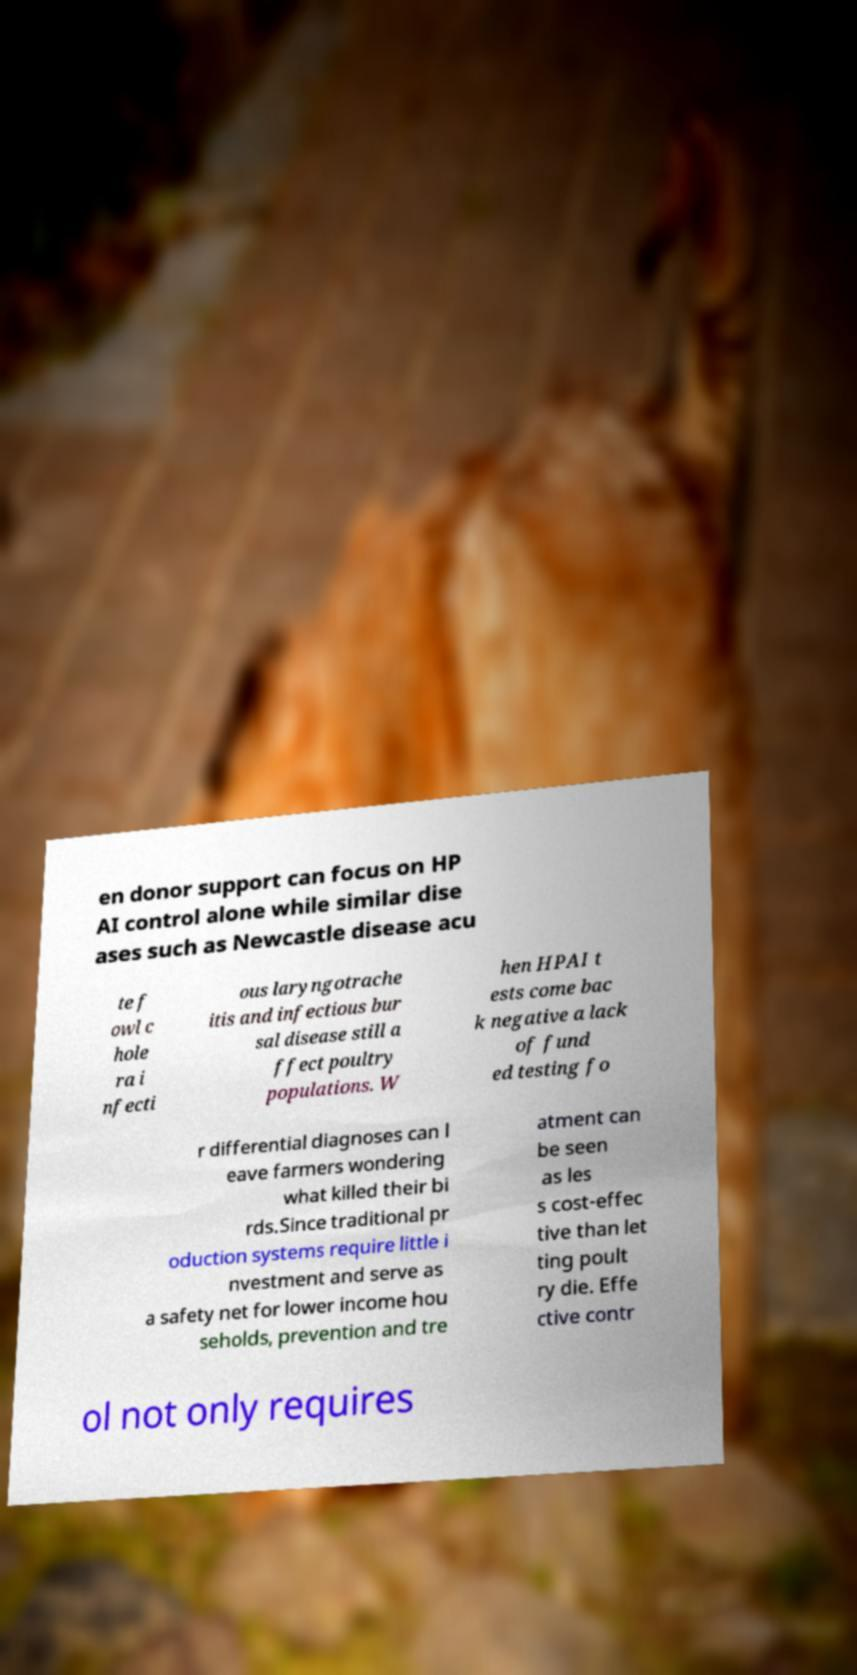Can you read and provide the text displayed in the image?This photo seems to have some interesting text. Can you extract and type it out for me? en donor support can focus on HP AI control alone while similar dise ases such as Newcastle disease acu te f owl c hole ra i nfecti ous laryngotrache itis and infectious bur sal disease still a ffect poultry populations. W hen HPAI t ests come bac k negative a lack of fund ed testing fo r differential diagnoses can l eave farmers wondering what killed their bi rds.Since traditional pr oduction systems require little i nvestment and serve as a safety net for lower income hou seholds, prevention and tre atment can be seen as les s cost-effec tive than let ting poult ry die. Effe ctive contr ol not only requires 